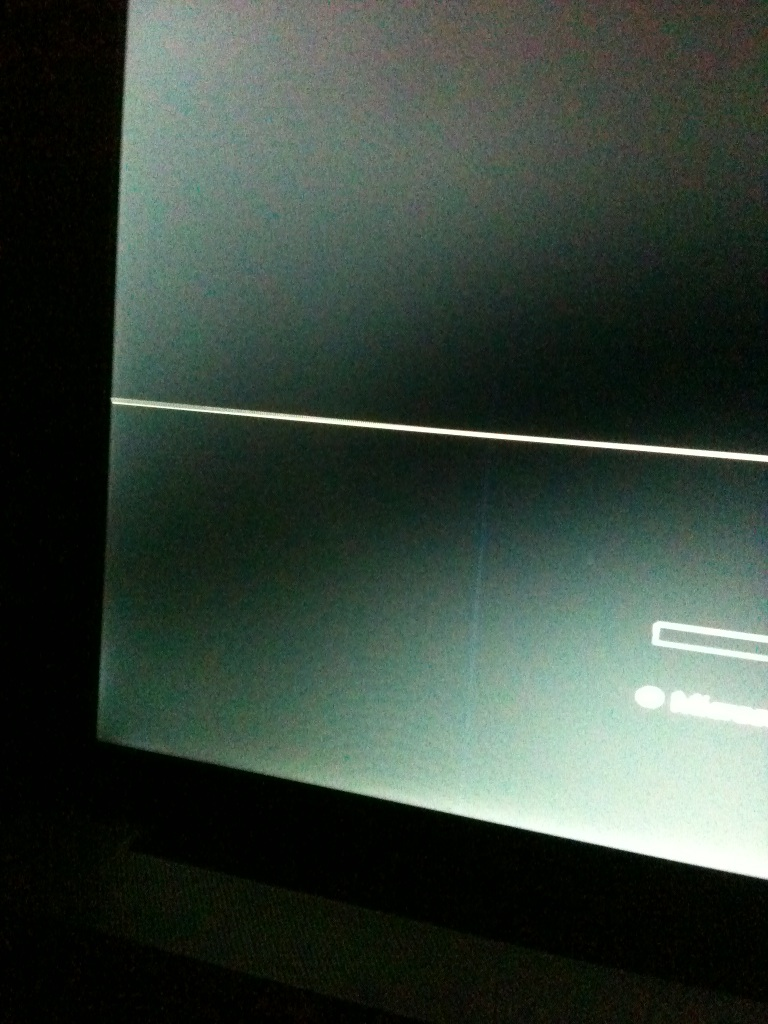What might the general use of this screen be, based on visible cues? Given the presence of what looks like a text input box at the bottom, it could be part of a software interface, possibly used for communications, data entry, or perhaps a loading screen of an application. Could the line indicate any type of specific functionality? The line could serve a decorative purpose, divide different sections of information, or be part of a minimalist user interface design. Without clearer visuals or context, it's a bit speculative to assign a specific function. 